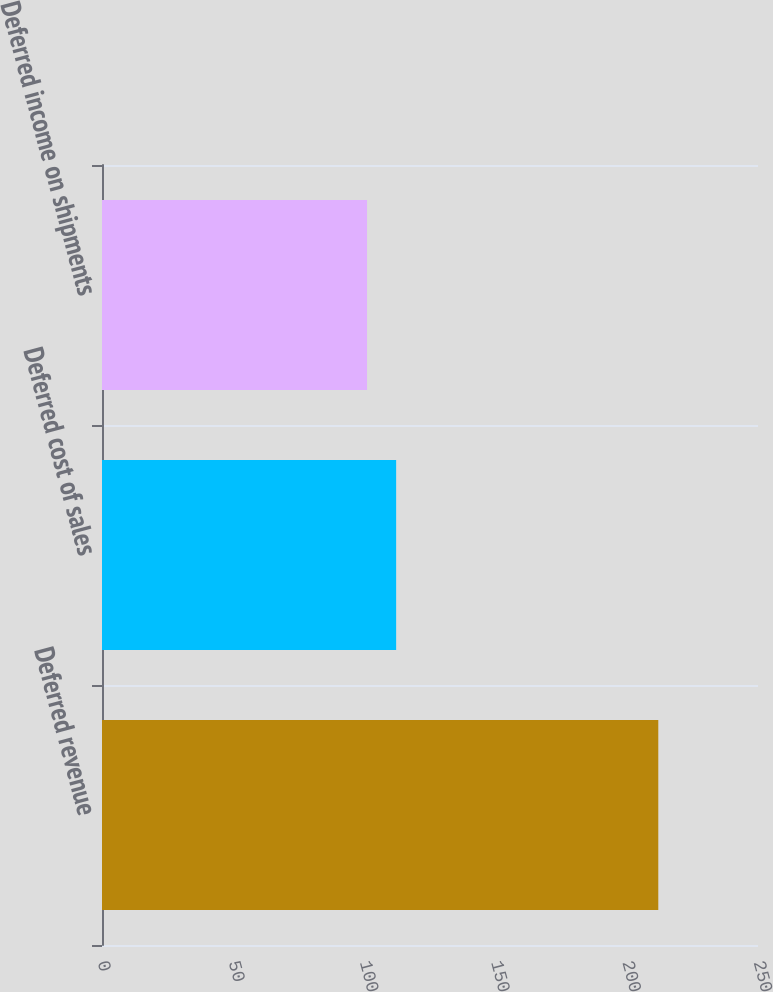<chart> <loc_0><loc_0><loc_500><loc_500><bar_chart><fcel>Deferred revenue<fcel>Deferred cost of sales<fcel>Deferred income on shipments<nl><fcel>212<fcel>112.1<fcel>101<nl></chart> 